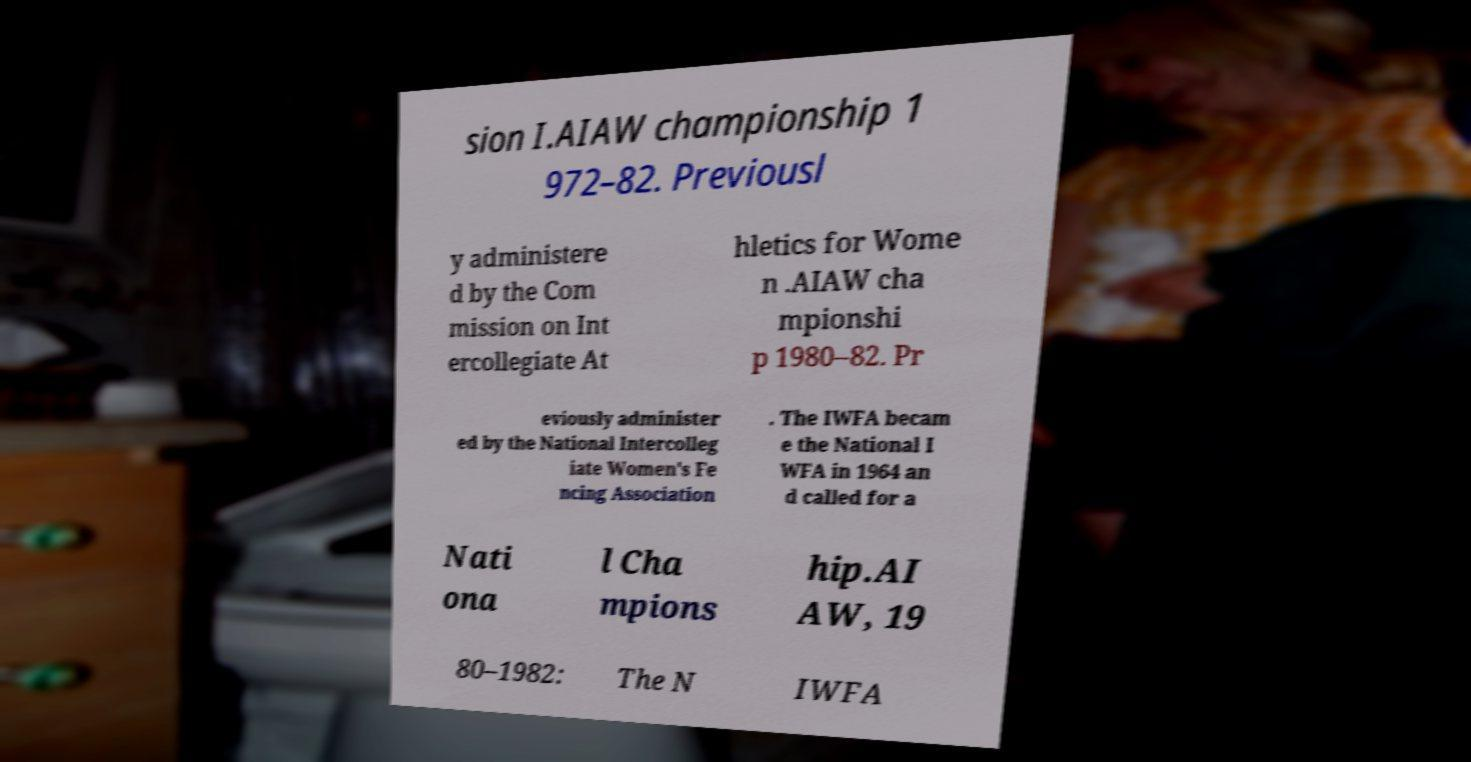For documentation purposes, I need the text within this image transcribed. Could you provide that? sion I.AIAW championship 1 972–82. Previousl y administere d by the Com mission on Int ercollegiate At hletics for Wome n .AIAW cha mpionshi p 1980–82. Pr eviously administer ed by the National Intercolleg iate Women's Fe ncing Association . The IWFA becam e the National I WFA in 1964 an d called for a Nati ona l Cha mpions hip.AI AW, 19 80–1982: The N IWFA 